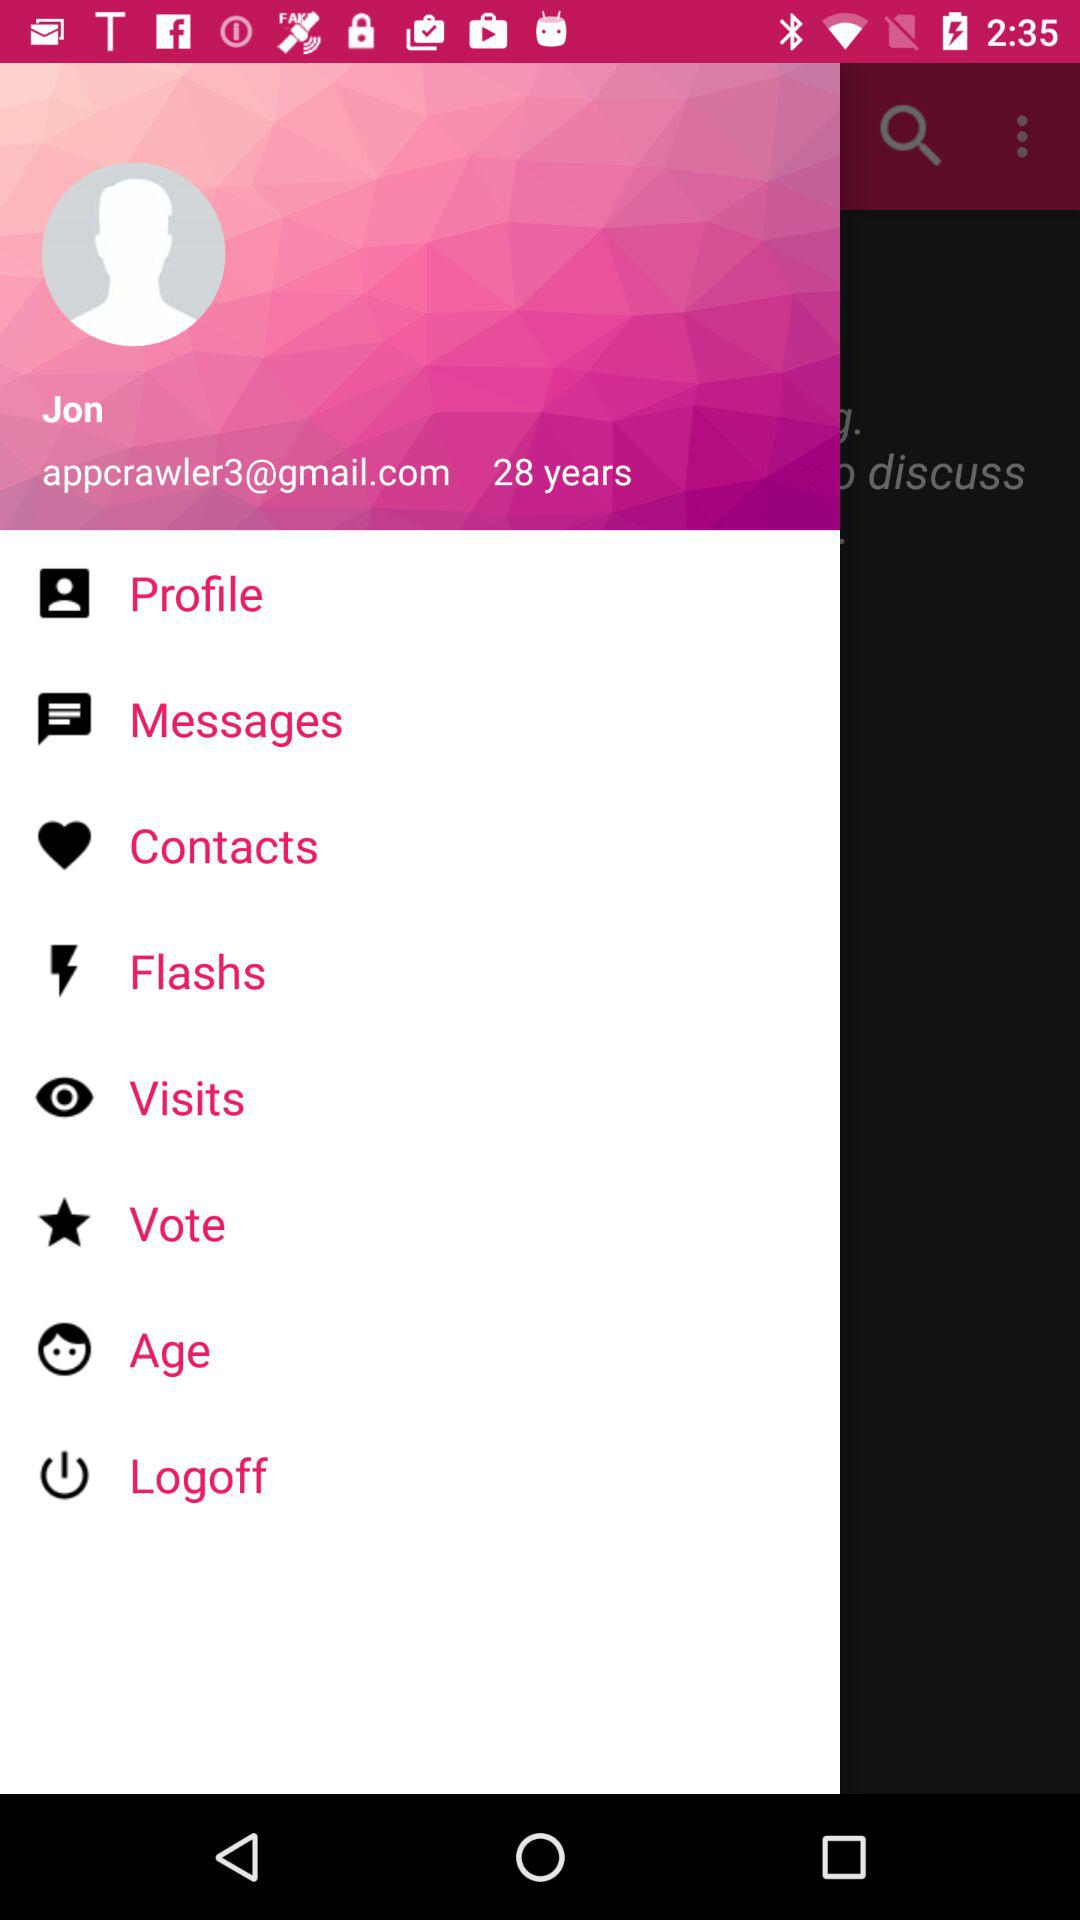What is the name of the user? The user name is Jon. 